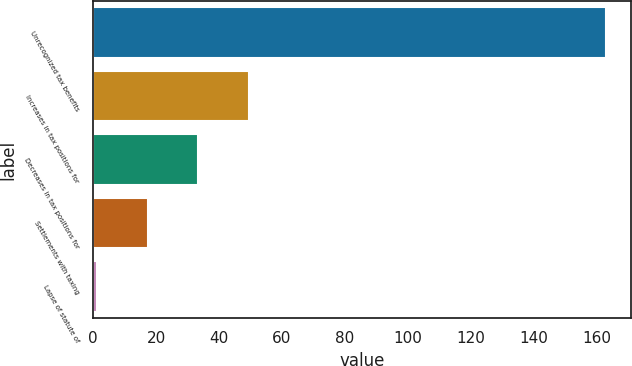Convert chart to OTSL. <chart><loc_0><loc_0><loc_500><loc_500><bar_chart><fcel>Unrecognized tax benefits<fcel>Increases in tax positions for<fcel>Decreases in tax positions for<fcel>Settlements with taxing<fcel>Lapse of statute of<nl><fcel>162.9<fcel>49.64<fcel>33.46<fcel>17.28<fcel>1.1<nl></chart> 